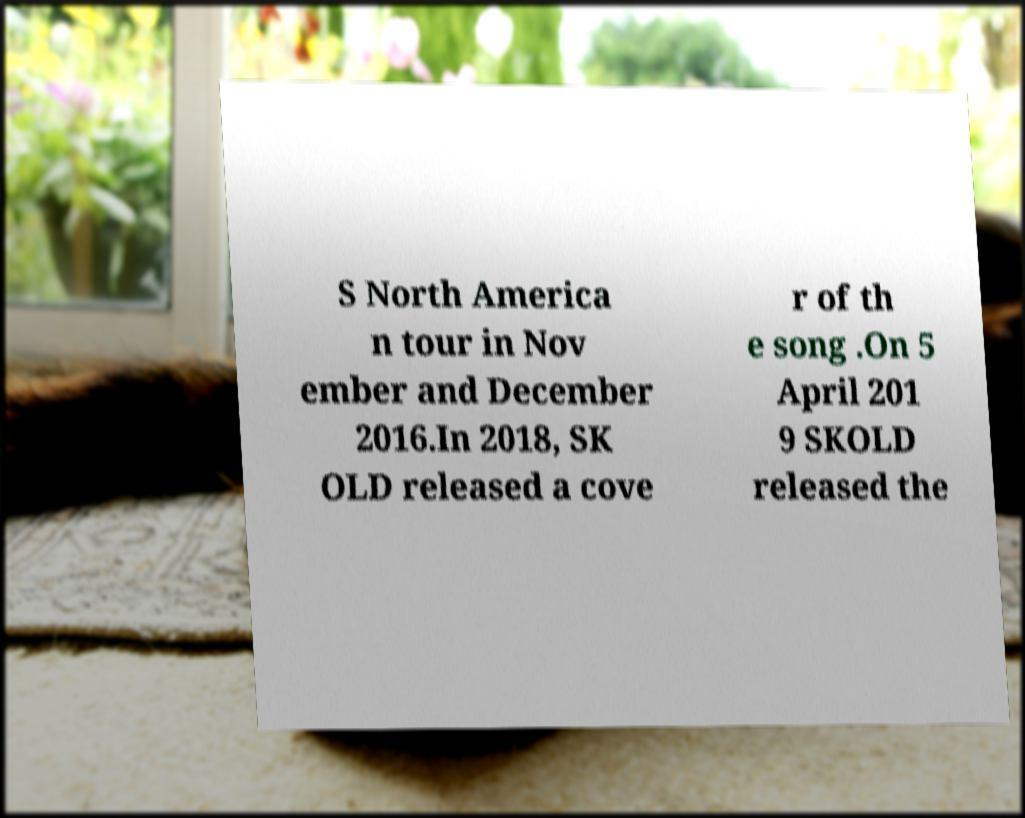There's text embedded in this image that I need extracted. Can you transcribe it verbatim? S North America n tour in Nov ember and December 2016.In 2018, SK OLD released a cove r of th e song .On 5 April 201 9 SKOLD released the 